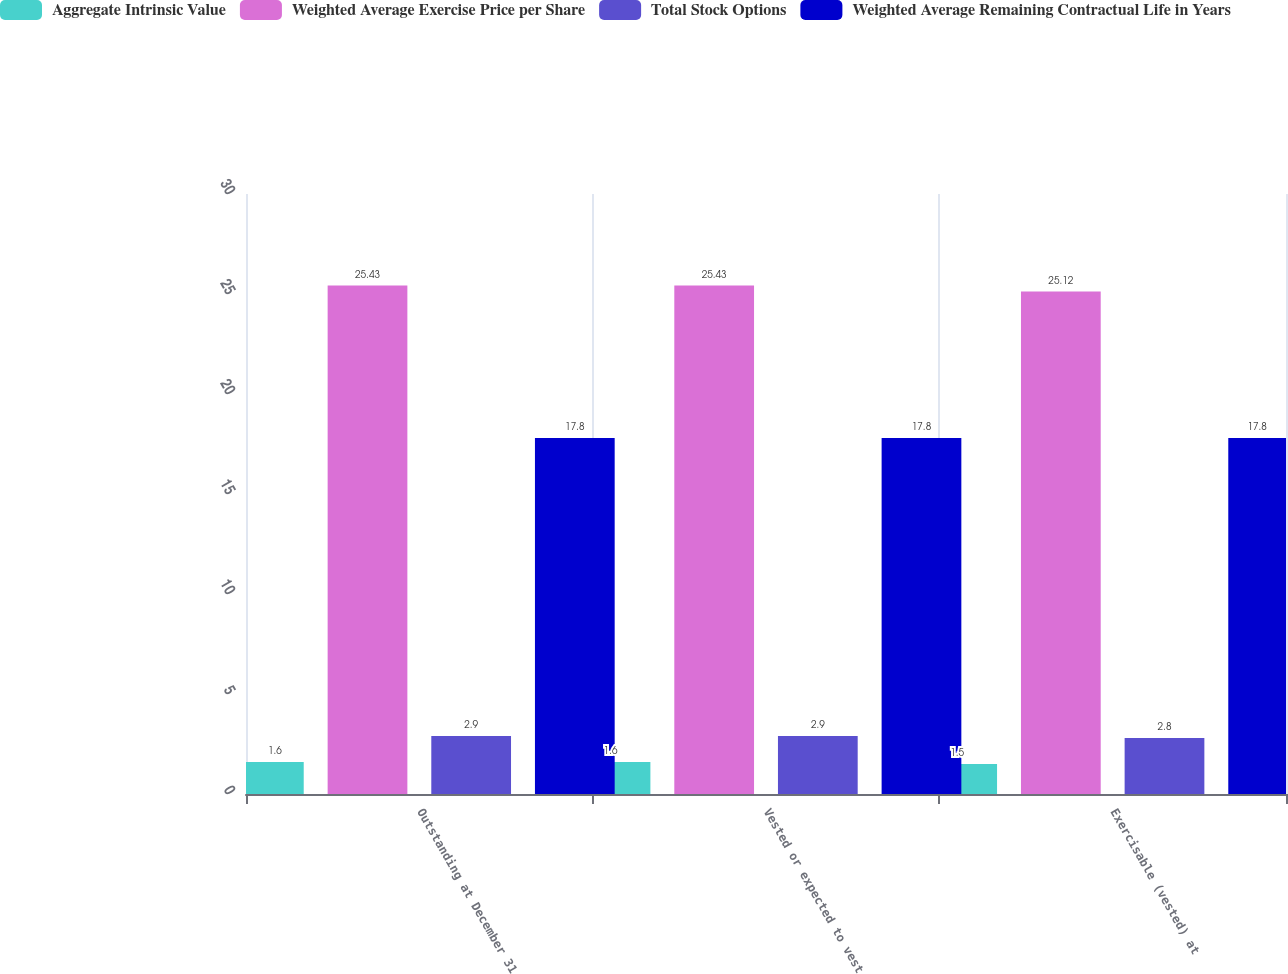Convert chart to OTSL. <chart><loc_0><loc_0><loc_500><loc_500><stacked_bar_chart><ecel><fcel>Outstanding at December 31<fcel>Vested or expected to vest<fcel>Exercisable (vested) at<nl><fcel>Aggregate Intrinsic Value<fcel>1.6<fcel>1.6<fcel>1.5<nl><fcel>Weighted Average Exercise Price per Share<fcel>25.43<fcel>25.43<fcel>25.12<nl><fcel>Total Stock Options<fcel>2.9<fcel>2.9<fcel>2.8<nl><fcel>Weighted Average Remaining Contractual Life in Years<fcel>17.8<fcel>17.8<fcel>17.8<nl></chart> 